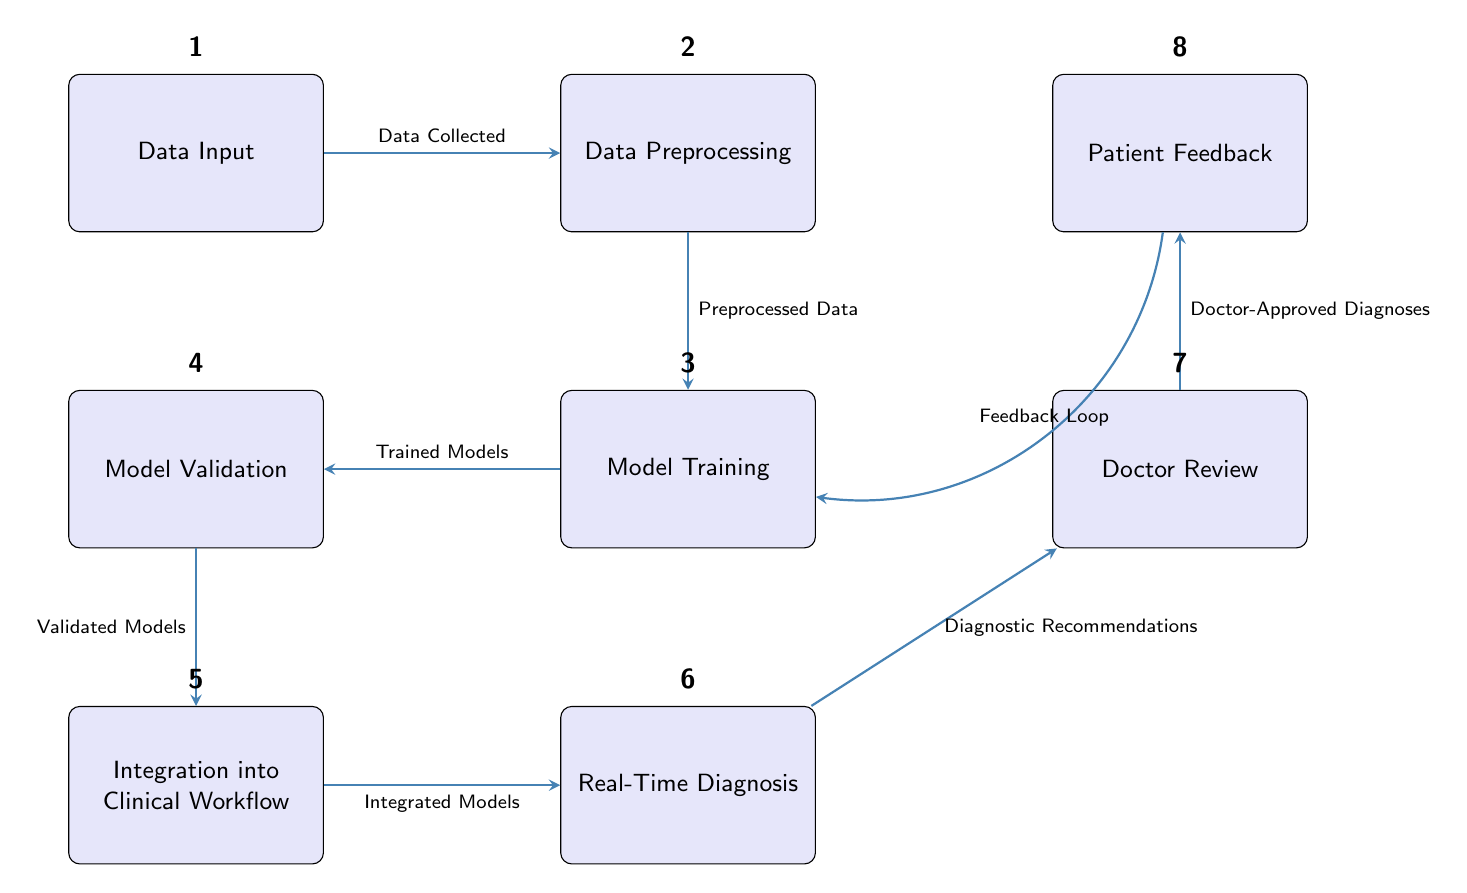What is the first step in the AI-enhanced medical diagnosis flow? The diagram indicates that the first step is 'Data Input', which is represented as the first node in the flowchart.
Answer: Data Input How many nodes are present in the diagram? By counting each distinct box in the diagram, we find there are eight nodes: Data Input, Data Preprocessing, Model Training, Model Validation, Integration into Clinical Workflow, Real-Time Diagnosis, Doctor Review, and Patient Feedback.
Answer: Eight What does the edge between Data Input and Data Preprocessing represent? The edge from Data Input to Data Preprocessing is labeled 'Data Collected', indicating the flow of information from the data collection phase to the preprocessing stage.
Answer: Data Collected What follows Model Training in the flow? The flow of the diagram shows that Model Training is followed by Model Validation, demonstrating the process of validating the trained models.
Answer: Model Validation What kind of feedback is looped back from Patient Feedback to Model Training? The diagram illustrates a feedback loop labeled 'Feedback Loop' that connects Patient Feedback back to Model Training, emphasizing the iterative nature of model improvement based on patient outcomes.
Answer: Feedback Loop Which node is directly responsible for giving diagnostic recommendations? The node labeled 'Real-Time Diagnosis' is directly associated with providing diagnostic recommendations, as indicated by the edge leading to the Doctor Review node that mentions 'Diagnostic Recommendations'.
Answer: Real-Time Diagnosis How does the integration into clinical workflow correlate with model validation? The integration into clinical workflow follows Model Validation, which means the validated models are incorporated into the clinical workflow to improve diagnosis processes. This correlation highlights the connection between ensuring model accuracy and practical application.
Answer: Integrated Models What is the last step of the AI integration process as per the diagram? According to the structure of the diagram, the last step of the AI integration process is 'Patient Feedback', which is obtained after the doctor's review and plays a crucial role in refining the diagnosis process.
Answer: Patient Feedback What type of edge connects Real-Time Diagnosis to Doctor Review? The edge connecting Real-Time Diagnosis to Doctor Review is a directed edge, indicating that real-time diagnosis leads to the review by a doctor and is labeled 'Diagnostic Recommendations'.
Answer: Diagnostic Recommendations 